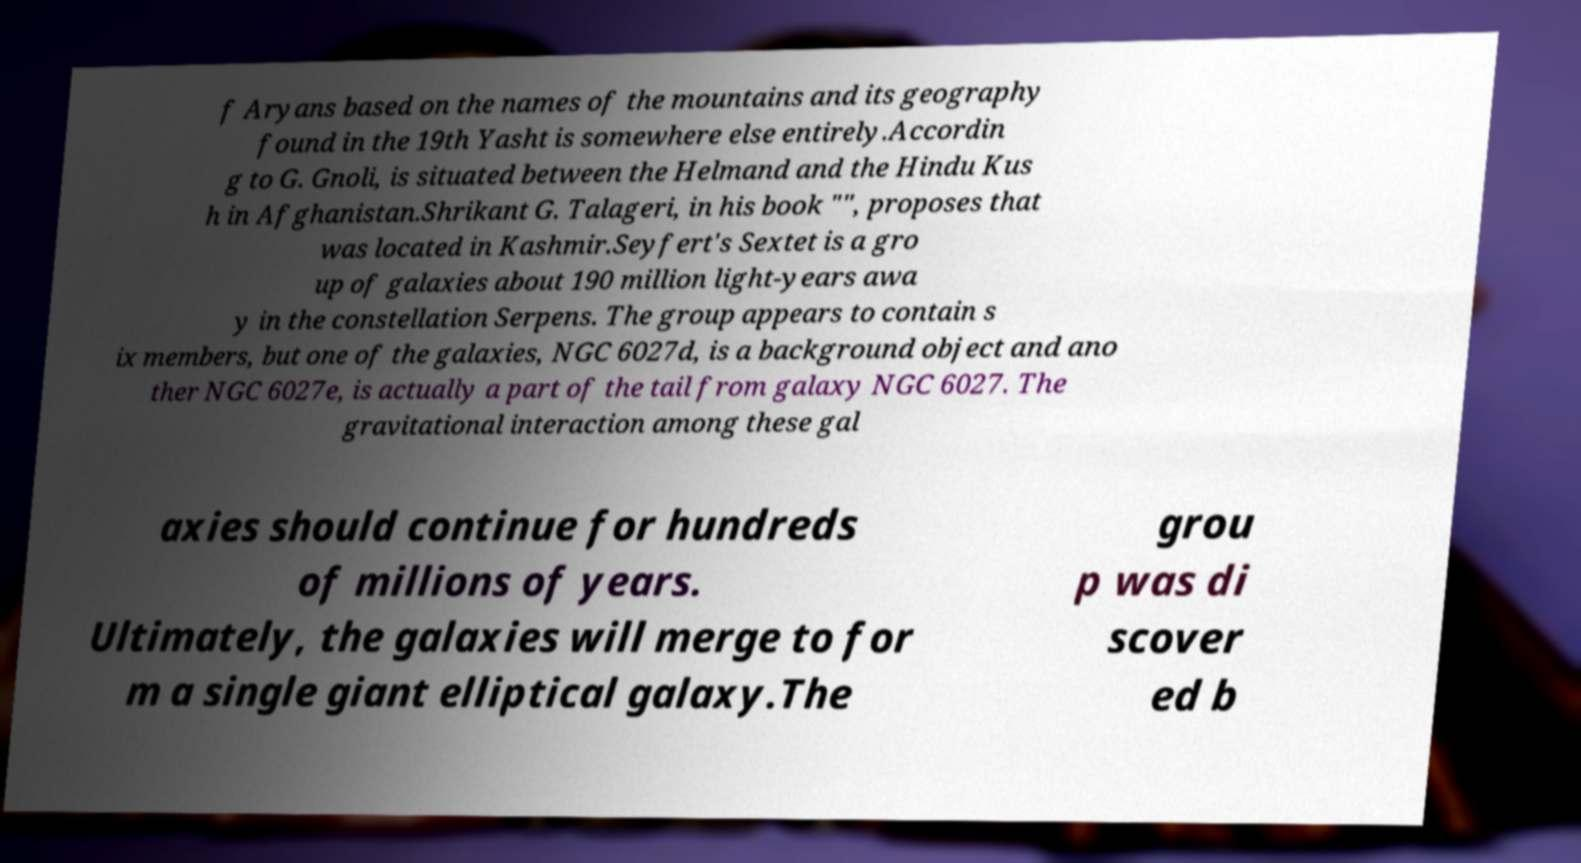Can you accurately transcribe the text from the provided image for me? f Aryans based on the names of the mountains and its geography found in the 19th Yasht is somewhere else entirely.Accordin g to G. Gnoli, is situated between the Helmand and the Hindu Kus h in Afghanistan.Shrikant G. Talageri, in his book "", proposes that was located in Kashmir.Seyfert's Sextet is a gro up of galaxies about 190 million light-years awa y in the constellation Serpens. The group appears to contain s ix members, but one of the galaxies, NGC 6027d, is a background object and ano ther NGC 6027e, is actually a part of the tail from galaxy NGC 6027. The gravitational interaction among these gal axies should continue for hundreds of millions of years. Ultimately, the galaxies will merge to for m a single giant elliptical galaxy.The grou p was di scover ed b 